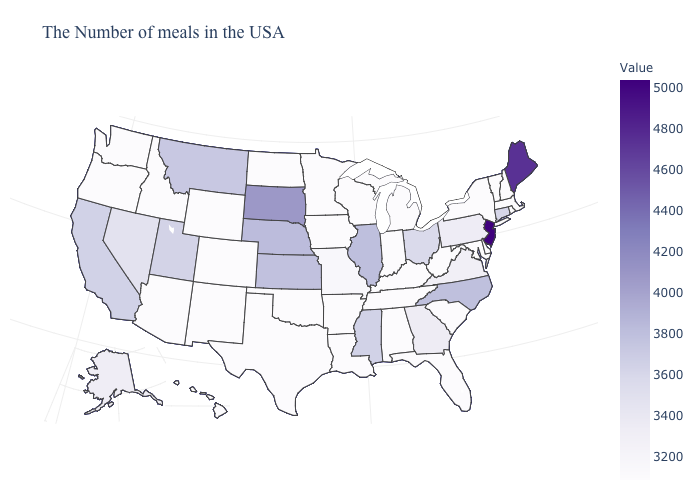Does Michigan have the lowest value in the MidWest?
Short answer required. Yes. Does South Dakota have the lowest value in the MidWest?
Quick response, please. No. Does Mississippi have a higher value than New Jersey?
Concise answer only. No. Does Pennsylvania have the lowest value in the Northeast?
Write a very short answer. No. 